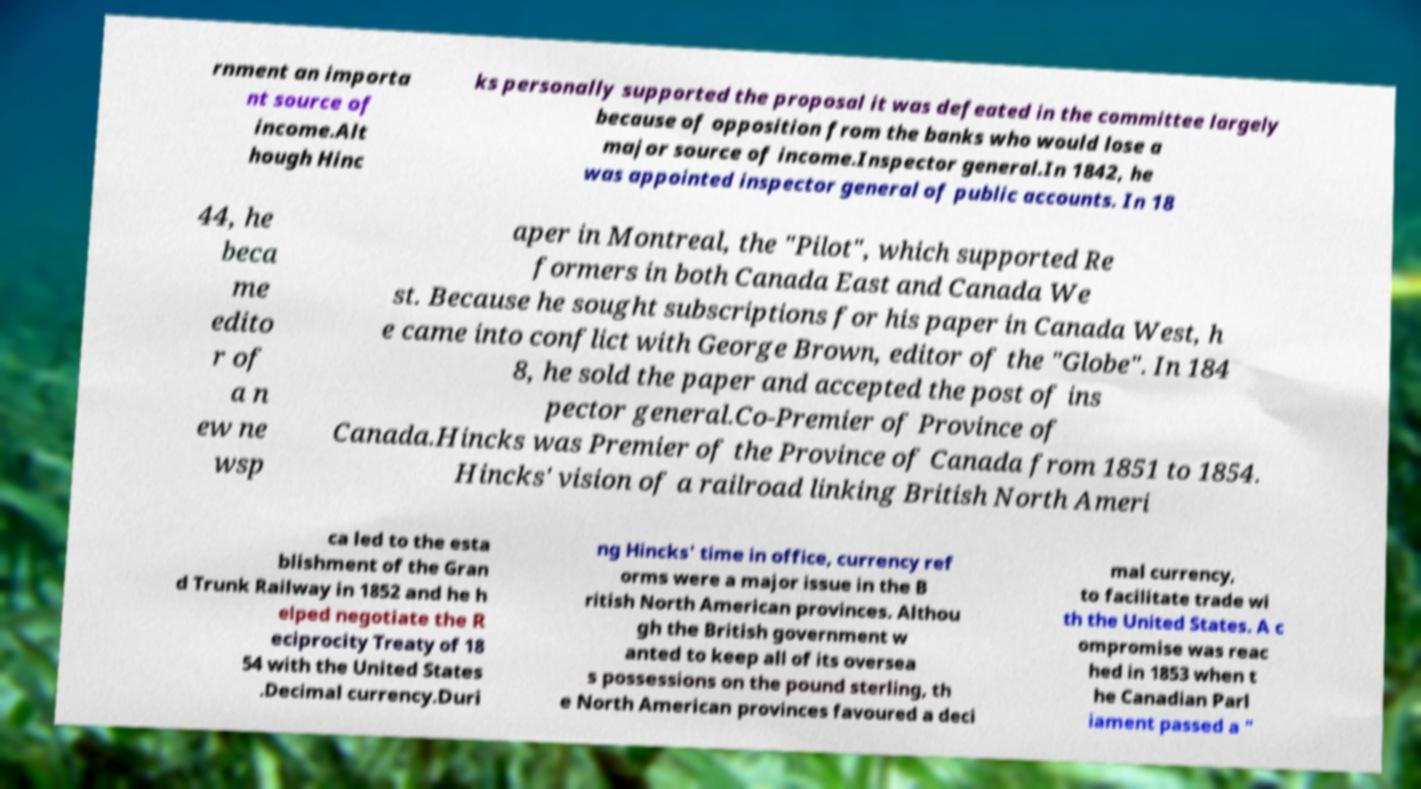Please read and relay the text visible in this image. What does it say? rnment an importa nt source of income.Alt hough Hinc ks personally supported the proposal it was defeated in the committee largely because of opposition from the banks who would lose a major source of income.Inspector general.In 1842, he was appointed inspector general of public accounts. In 18 44, he beca me edito r of a n ew ne wsp aper in Montreal, the "Pilot", which supported Re formers in both Canada East and Canada We st. Because he sought subscriptions for his paper in Canada West, h e came into conflict with George Brown, editor of the "Globe". In 184 8, he sold the paper and accepted the post of ins pector general.Co-Premier of Province of Canada.Hincks was Premier of the Province of Canada from 1851 to 1854. Hincks' vision of a railroad linking British North Ameri ca led to the esta blishment of the Gran d Trunk Railway in 1852 and he h elped negotiate the R eciprocity Treaty of 18 54 with the United States .Decimal currency.Duri ng Hincks' time in office, currency ref orms were a major issue in the B ritish North American provinces. Althou gh the British government w anted to keep all of its oversea s possessions on the pound sterling, th e North American provinces favoured a deci mal currency, to facilitate trade wi th the United States. A c ompromise was reac hed in 1853 when t he Canadian Parl iament passed a " 